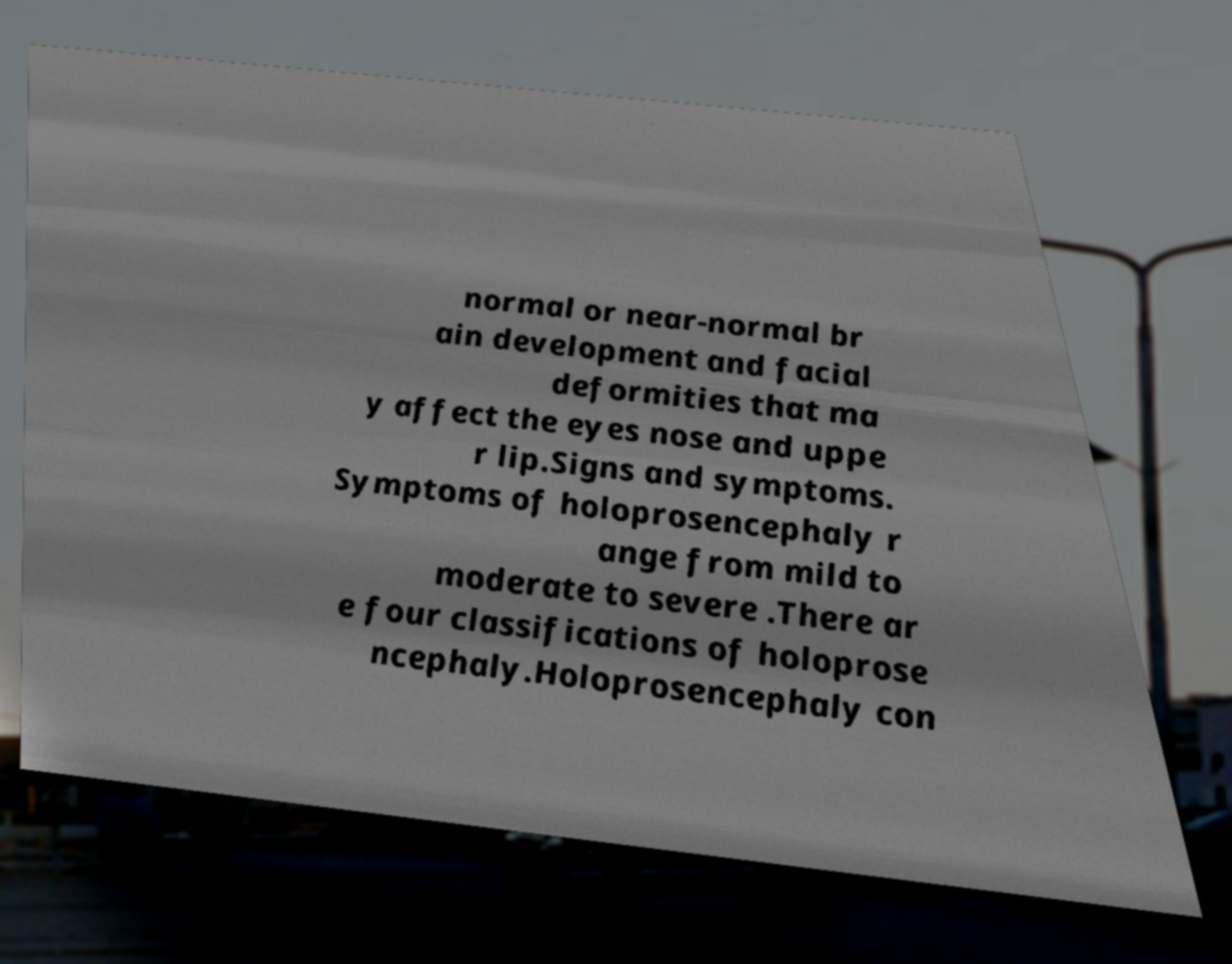Can you read and provide the text displayed in the image?This photo seems to have some interesting text. Can you extract and type it out for me? normal or near-normal br ain development and facial deformities that ma y affect the eyes nose and uppe r lip.Signs and symptoms. Symptoms of holoprosencephaly r ange from mild to moderate to severe .There ar e four classifications of holoprose ncephaly.Holoprosencephaly con 